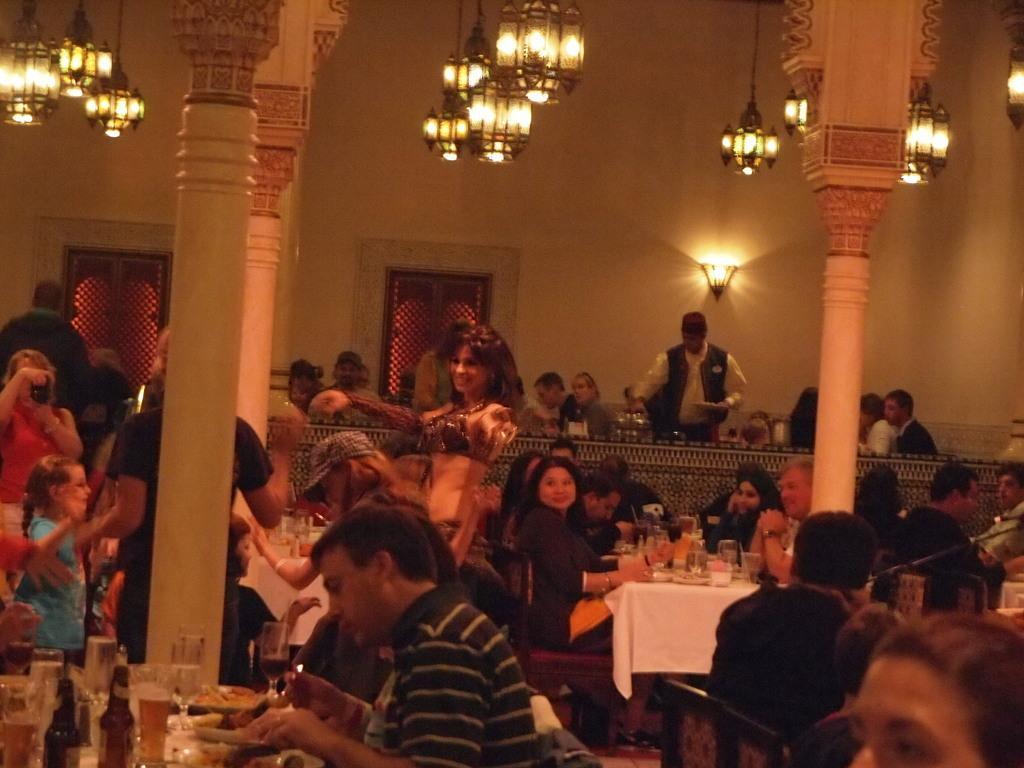Please provide a concise description of this image. Many persons are sitting and standing in this room. There are many pillars. On the ceiling there are chandelier. In the background there is a wall. On the wall there are two doors and light. There are many tables and chairs. On the table there are bottles, glasses, plates and many food items. On the left side a woman holding a camera. 